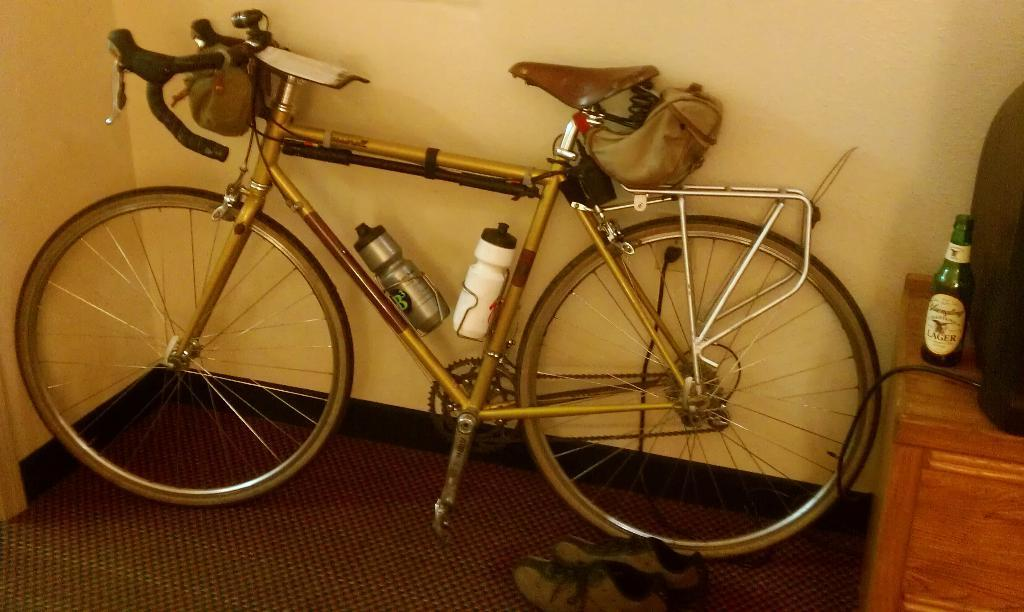What is located near a wall in the image? There is a bicycle near a wall in the image. What can be seen on a table in the image? There is a bottle and a speaker on a table in the image. What type of footwear is on the floor in the image? There are shoes on the floor in the image. How many holes are visible in the shoes on the floor in the image? There is no information about the shoes' condition or the presence of holes in the image. 